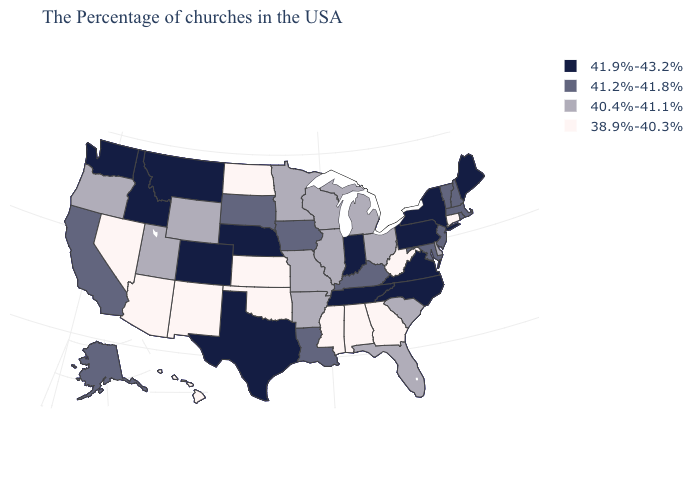Name the states that have a value in the range 40.4%-41.1%?
Concise answer only. Delaware, South Carolina, Ohio, Florida, Michigan, Wisconsin, Illinois, Missouri, Arkansas, Minnesota, Wyoming, Utah, Oregon. How many symbols are there in the legend?
Quick response, please. 4. What is the lowest value in the Northeast?
Give a very brief answer. 38.9%-40.3%. Name the states that have a value in the range 40.4%-41.1%?
Keep it brief. Delaware, South Carolina, Ohio, Florida, Michigan, Wisconsin, Illinois, Missouri, Arkansas, Minnesota, Wyoming, Utah, Oregon. Name the states that have a value in the range 40.4%-41.1%?
Short answer required. Delaware, South Carolina, Ohio, Florida, Michigan, Wisconsin, Illinois, Missouri, Arkansas, Minnesota, Wyoming, Utah, Oregon. Which states have the lowest value in the USA?
Concise answer only. Connecticut, West Virginia, Georgia, Alabama, Mississippi, Kansas, Oklahoma, North Dakota, New Mexico, Arizona, Nevada, Hawaii. What is the lowest value in the USA?
Answer briefly. 38.9%-40.3%. Among the states that border New Mexico , which have the lowest value?
Answer briefly. Oklahoma, Arizona. Does the first symbol in the legend represent the smallest category?
Quick response, please. No. Among the states that border Arizona , which have the lowest value?
Be succinct. New Mexico, Nevada. What is the lowest value in states that border Connecticut?
Give a very brief answer. 41.2%-41.8%. Name the states that have a value in the range 41.9%-43.2%?
Concise answer only. Maine, New York, Pennsylvania, Virginia, North Carolina, Indiana, Tennessee, Nebraska, Texas, Colorado, Montana, Idaho, Washington. What is the value of South Carolina?
Be succinct. 40.4%-41.1%. What is the value of Colorado?
Answer briefly. 41.9%-43.2%. Among the states that border Kentucky , does Missouri have the highest value?
Quick response, please. No. 